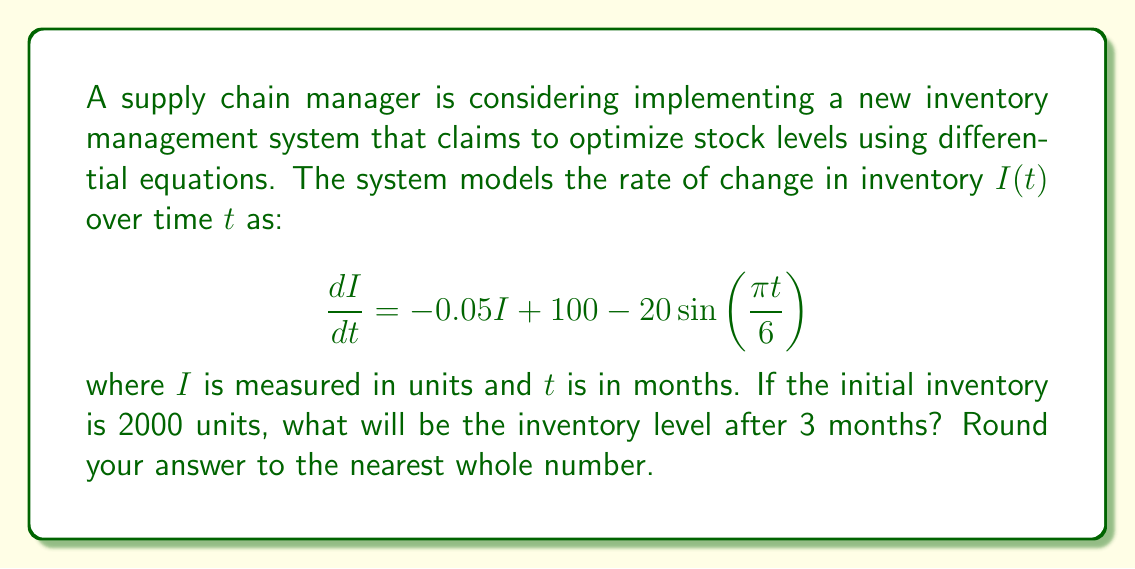Help me with this question. To solve this problem, we need to integrate the differential equation:

1) The general solution to this differential equation is:
   $$I(t) = Ce^{-0.05t} + 2000 + 120\cos(\frac{\pi t}{6})$$
   where $C$ is a constant we need to determine.

2) Using the initial condition $I(0) = 2000$:
   $$2000 = C + 2000 + 120$$
   $$C = -120$$

3) Therefore, the particular solution is:
   $$I(t) = -120e^{-0.05t} + 2000 + 120\cos(\frac{\pi t}{6})$$

4) To find the inventory after 3 months, we substitute $t = 3$:
   $$I(3) = -120e^{-0.05(3)} + 2000 + 120\cos(\frac{\pi (3)}{6})$$

5) Calculating:
   $$I(3) = -120(0.8607) + 2000 + 120\cos(\frac{\pi}{2})$$
   $$I(3) = -103.28 + 2000 + 120(0)$$
   $$I(3) = 1896.72$$

6) Rounding to the nearest whole number:
   $$I(3) \approx 1897$$
Answer: 1897 units 